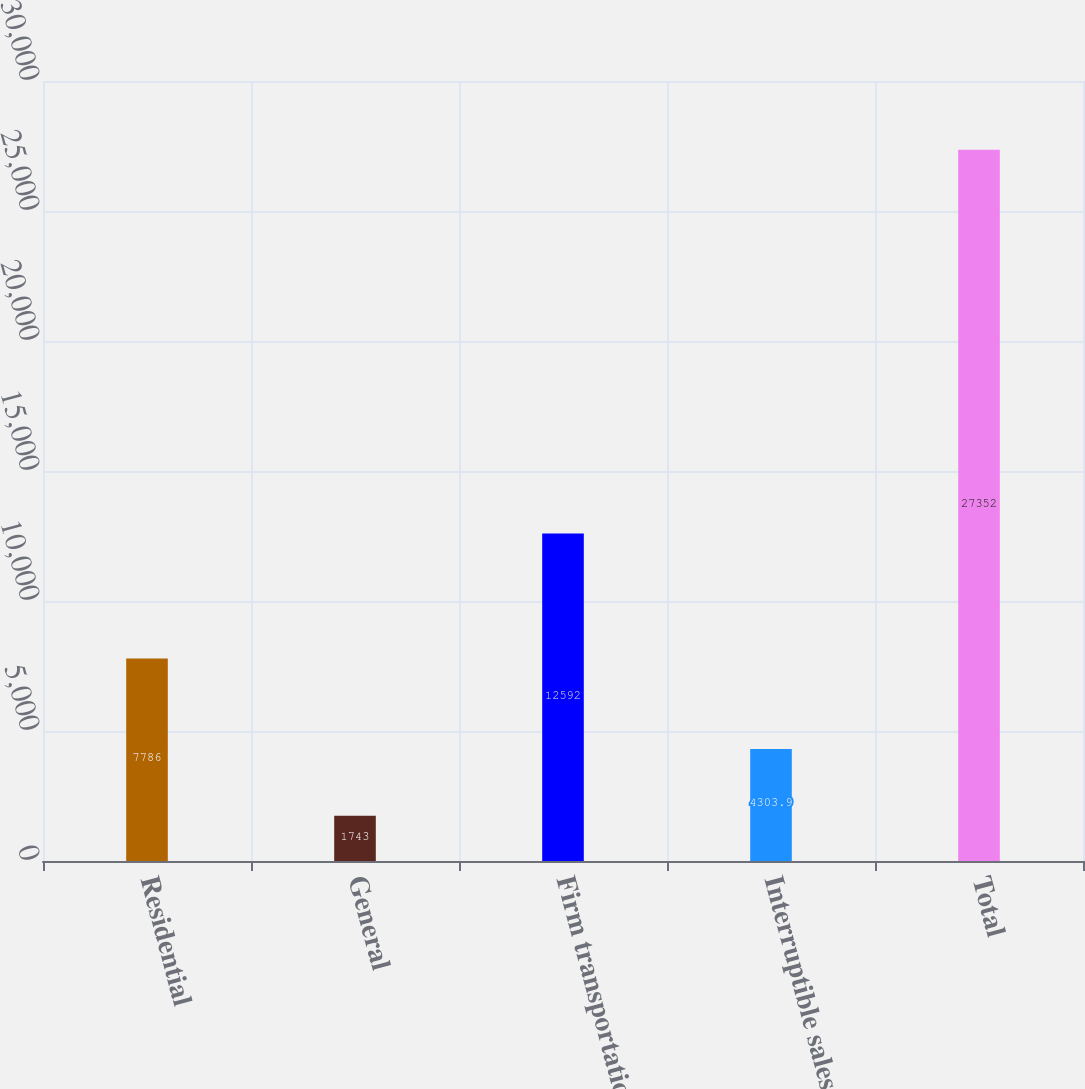Convert chart. <chart><loc_0><loc_0><loc_500><loc_500><bar_chart><fcel>Residential<fcel>General<fcel>Firm transportation<fcel>Interruptible sales<fcel>Total<nl><fcel>7786<fcel>1743<fcel>12592<fcel>4303.9<fcel>27352<nl></chart> 